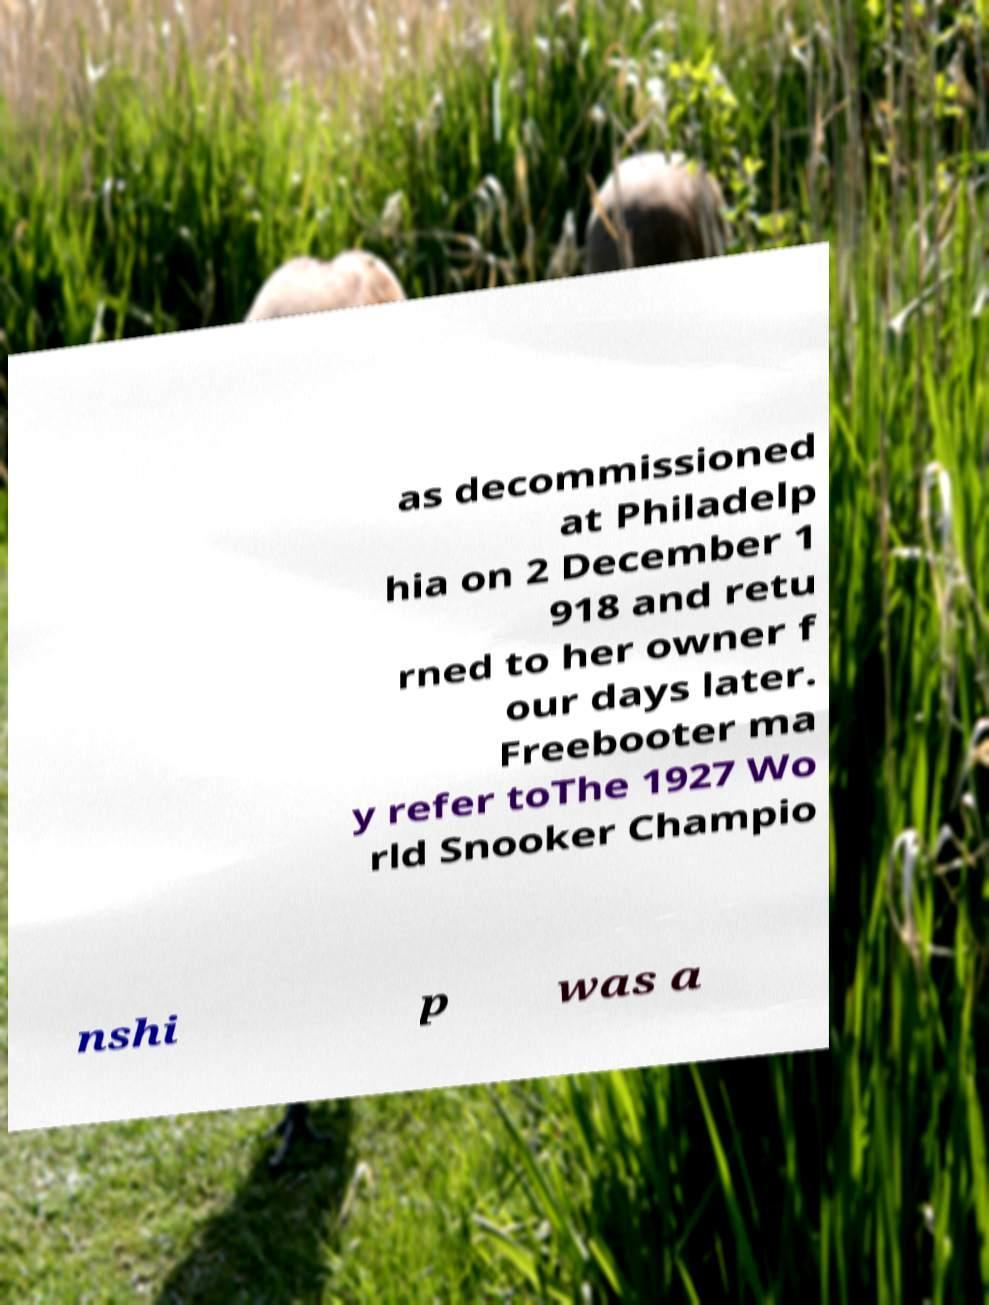Could you extract and type out the text from this image? as decommissioned at Philadelp hia on 2 December 1 918 and retu rned to her owner f our days later. Freebooter ma y refer toThe 1927 Wo rld Snooker Champio nshi p was a 